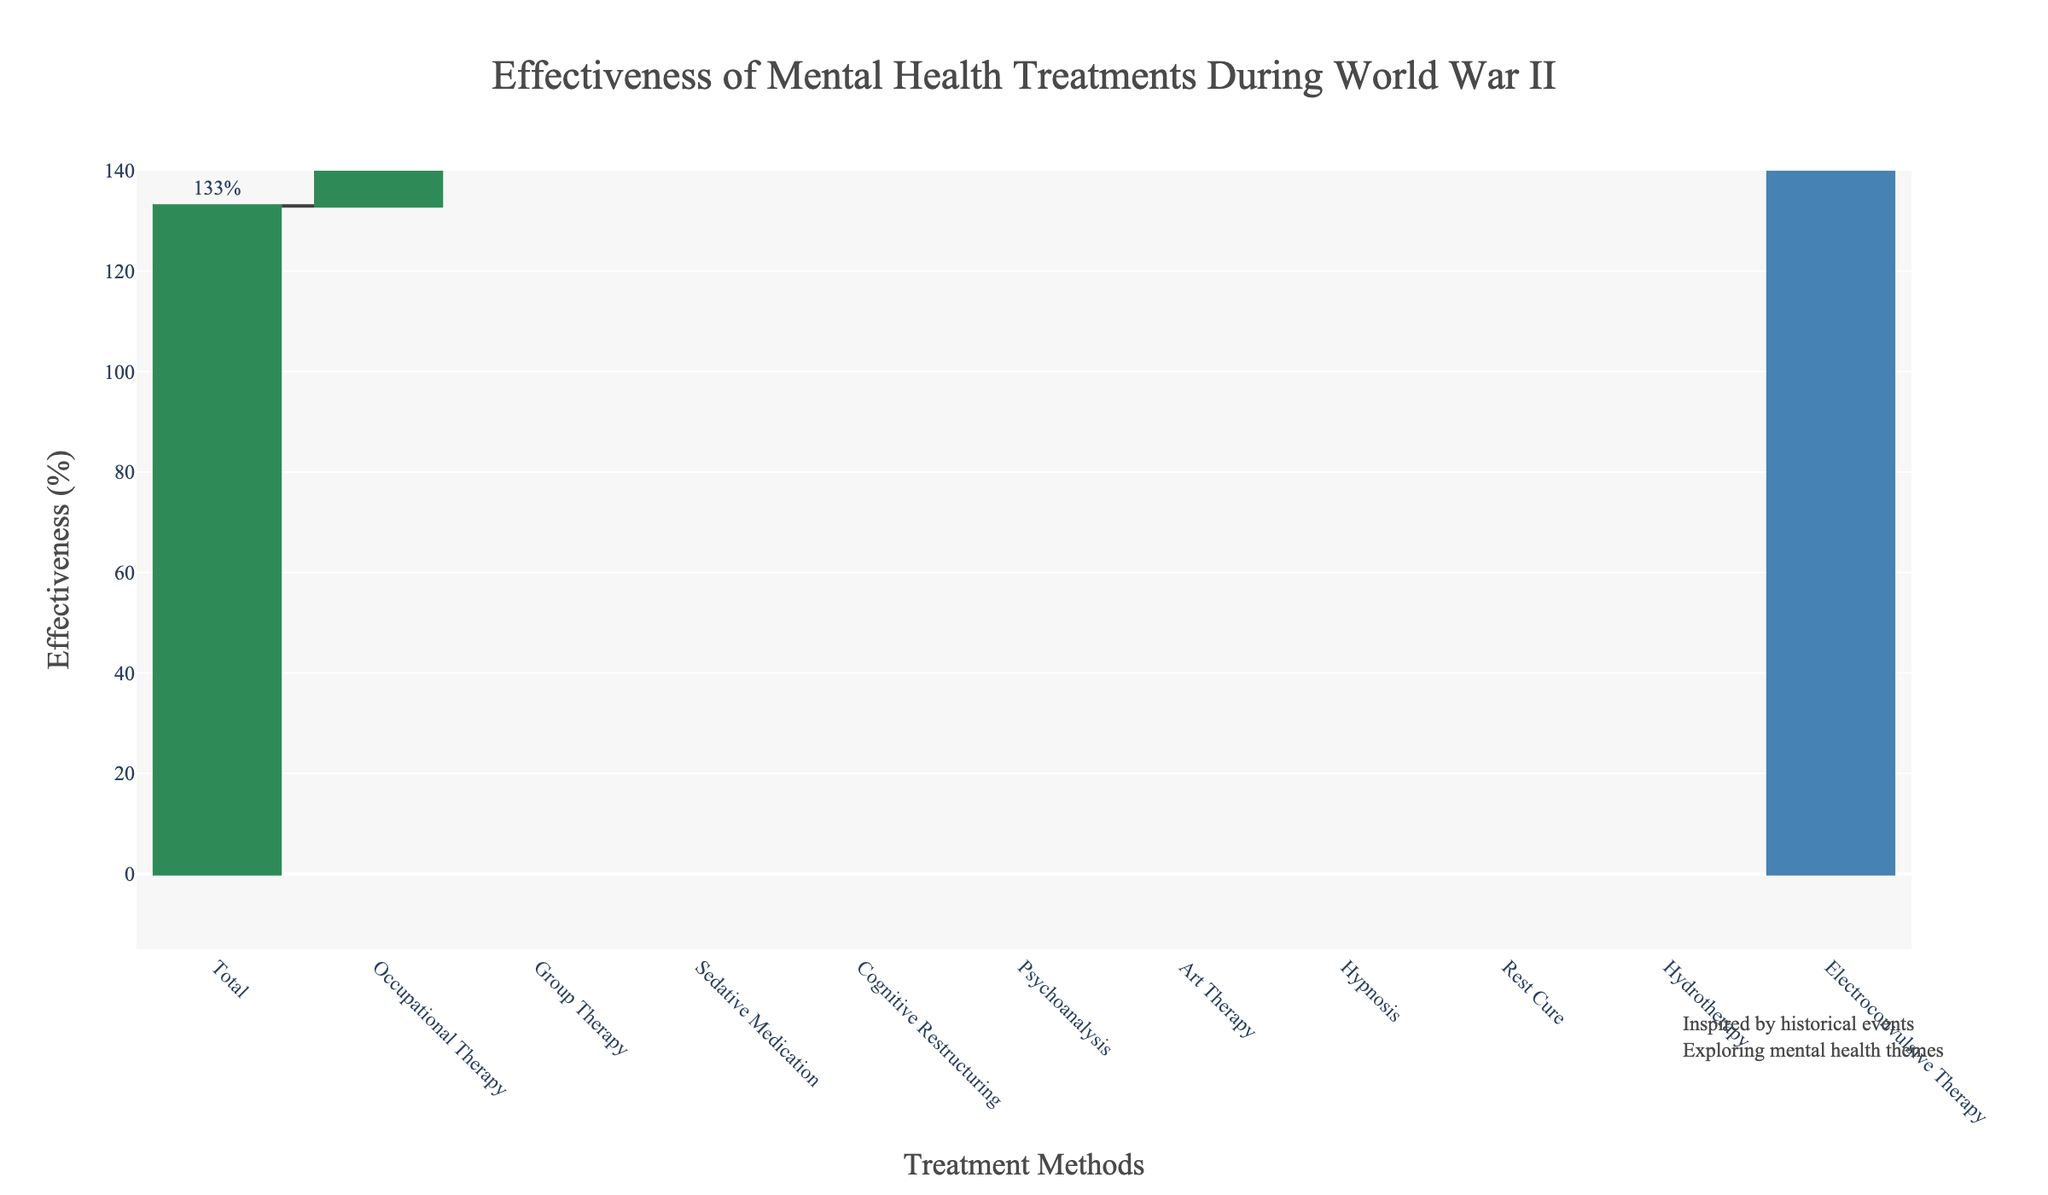What's the title of the figure? The title is typically located at the top of the chart and provides a summary of the information displayed. In this figure, the title reads "Effectiveness of Mental Health Treatments During World War II."
Answer: "Effectiveness of Mental Health Treatments During World War II." What is the effectiveness percentage of Cognitive Restructuring? Find the bar labeled "Cognitive Restructuring" and read the percentage value displayed next to it. It says "18%."
Answer: 18% Which treatment method has the lowest effectiveness? Look for the bar with the smallest or most negative value. The treatment method "Electroconvulsive Therapy" has the lowest effectiveness at -10%.
Answer: Electroconvulsive Therapy How many treatment methods have an effectiveness equal to or greater than 20%? Count all the bars with values 20% or higher. Here, Group Therapy, Occupational Therapy, and Sedative Medication have values of 25%, 30%, and 20%, respectively. This totals three methods.
Answer: 3 By how much does Group Therapy's effectiveness exceed that of Hypnosis? Find the effectiveness percentages of both treatments. Group Therapy is at 25% and Hypnosis is at 10%. Subtract 10 from 25 to get the difference. 25 - 10 = 15.
Answer: 15% What is the combined effectiveness of Art Therapy and Rest Cure? Find the effectiveness percentages for Art Therapy and Rest Cure, which are 12% and 8%, respectively. Add them together: 12 + 8 = 20%.
Answer: 20% What total effectiveness is displayed at the end of the waterfall chart? The last bar in a waterfall chart usually represents the cumulative total of all previous values. Here, the total effectiveness is shown as 133%.
Answer: 133% Is the effectiveness of Psychoanalysis greater than that of Hydotherapy? Compare the percentages: Psychoanalysis is at 15%, while Hydrotherapy is at 5%. Since 15% is greater than 5%, Psychoanalysis is more effective.
Answer: Yes If you exclude the negative effectiveness of Electroconvulsive Therapy, what would the new total effectiveness be? The total effectiveness is 133%. The effectiveness of Electroconvulsive Therapy is -10%. If excluded, the new total would be 133 - (-10) = 143%.
Answer: 143% What is the median effectiveness value of all treatment methods excluding the total? Sort the effectiveness values of the treatment methods (from highest to lowest): 30%, 25%, 20%, 18%, 15%, 12%, 10%, 8%, 5%, -10%. The median is the middle value. Since there are ten methods, the median is the average of the 5th and 6th values. (15+12)/2 = 13.5%.
Answer: 13.5% 